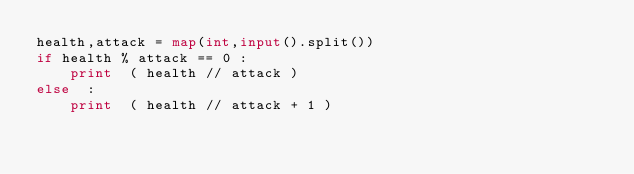Convert code to text. <code><loc_0><loc_0><loc_500><loc_500><_Python_>health,attack = map(int,input().split())
if health % attack == 0 :
    print  ( health // attack ) 
else  :
    print  ( health // attack + 1 )
</code> 